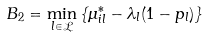Convert formula to latex. <formula><loc_0><loc_0><loc_500><loc_500>B _ { 2 } = \min _ { l \in \mathcal { L } } \left \{ \mu ^ { * } _ { i l } - \lambda _ { l } ( 1 - p _ { l } ) \right \}</formula> 